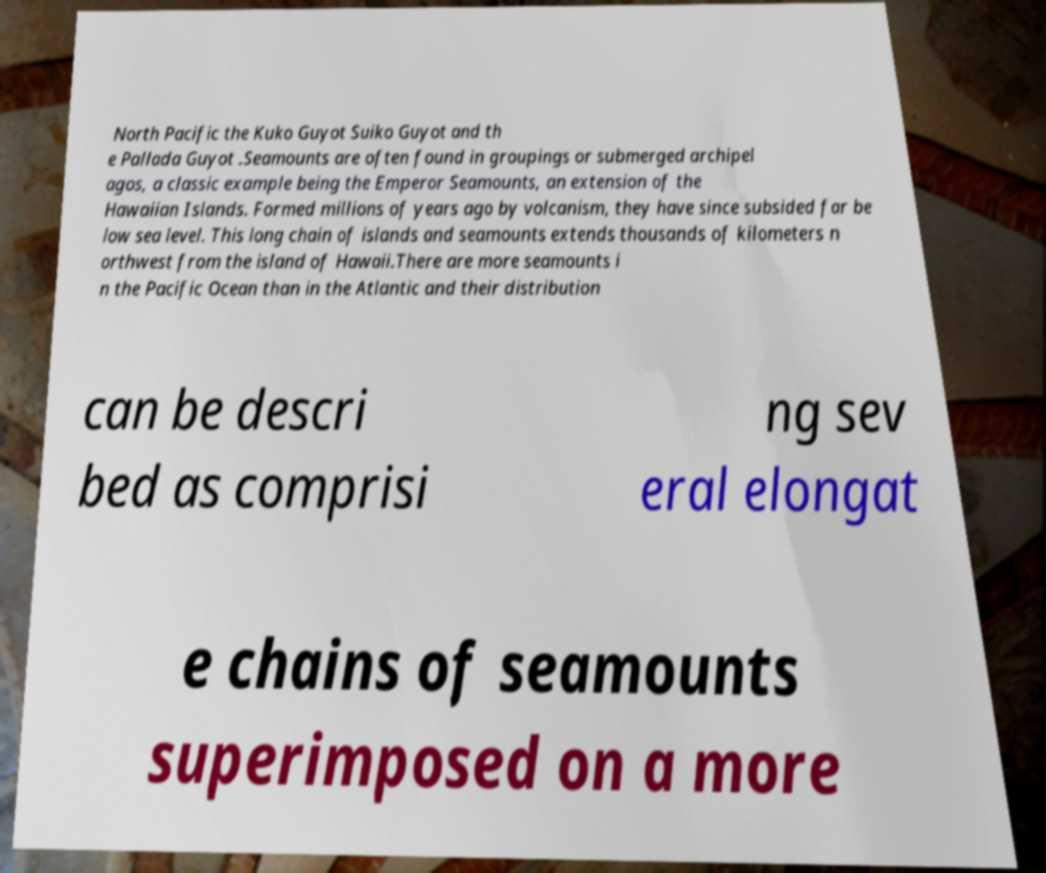Could you assist in decoding the text presented in this image and type it out clearly? North Pacific the Kuko Guyot Suiko Guyot and th e Pallada Guyot .Seamounts are often found in groupings or submerged archipel agos, a classic example being the Emperor Seamounts, an extension of the Hawaiian Islands. Formed millions of years ago by volcanism, they have since subsided far be low sea level. This long chain of islands and seamounts extends thousands of kilometers n orthwest from the island of Hawaii.There are more seamounts i n the Pacific Ocean than in the Atlantic and their distribution can be descri bed as comprisi ng sev eral elongat e chains of seamounts superimposed on a more 